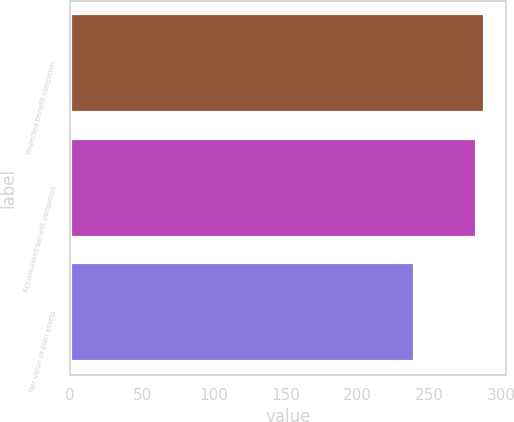Convert chart to OTSL. <chart><loc_0><loc_0><loc_500><loc_500><bar_chart><fcel>Projected benefit obligation<fcel>Accumulated benefit obligation<fcel>Fair value of plan assets<nl><fcel>288.8<fcel>283.1<fcel>240.1<nl></chart> 